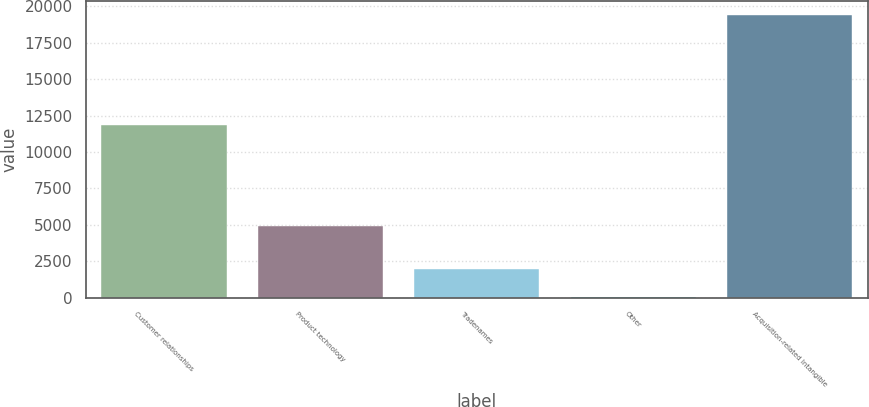Convert chart. <chart><loc_0><loc_0><loc_500><loc_500><bar_chart><fcel>Customer relationships<fcel>Product technology<fcel>Tradenames<fcel>Other<fcel>Acquisition-related Intangible<nl><fcel>11866.8<fcel>4898.1<fcel>1974.18<fcel>34.2<fcel>19434<nl></chart> 